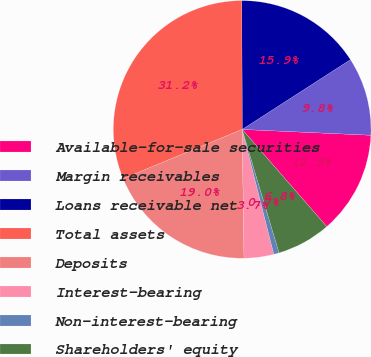<chart> <loc_0><loc_0><loc_500><loc_500><pie_chart><fcel>Available-for-sale securities<fcel>Margin receivables<fcel>Loans receivable net<fcel>Total assets<fcel>Deposits<fcel>Interest-bearing<fcel>Non-interest-bearing<fcel>Shareholders' equity<nl><fcel>12.88%<fcel>9.83%<fcel>15.93%<fcel>31.2%<fcel>18.99%<fcel>3.72%<fcel>0.67%<fcel>6.78%<nl></chart> 